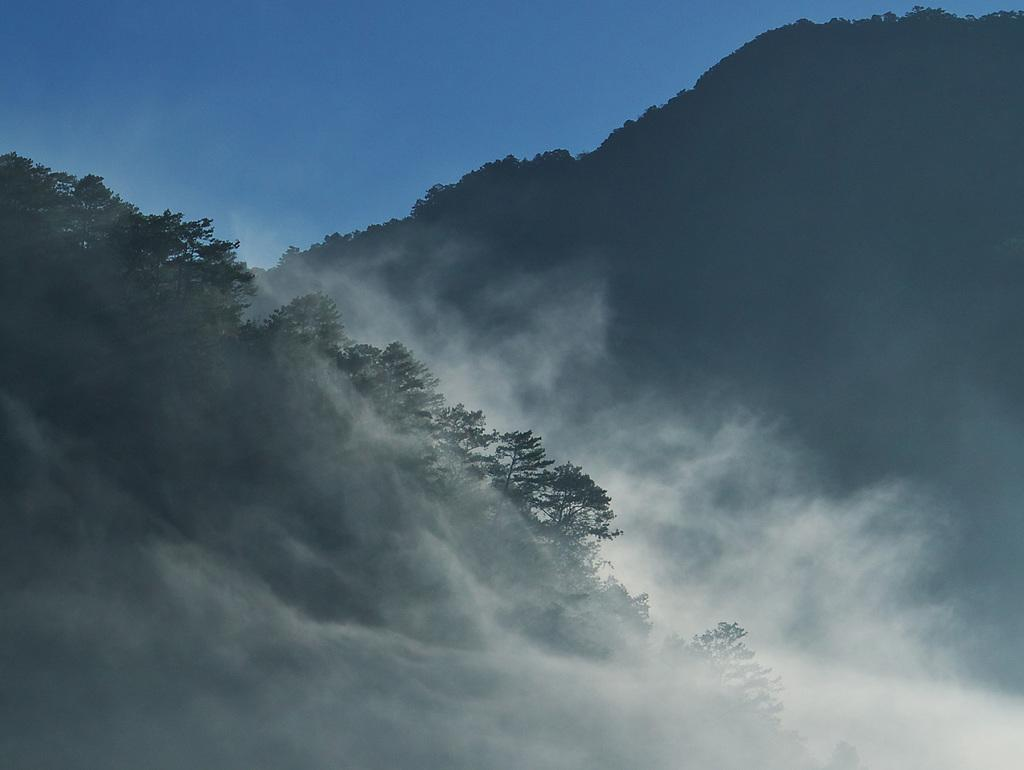What is present in the front of the image? There is fog in the front of the image. What can be seen on the left side of the image? There are trees on the left side of the image. What is visible at the top of the image? The sky is visible at the top of the image. What month is it in the image? The month cannot be determined from the image, as there is no information about the time of year. Can you tell me how many people are running in the image? There are no people visible in the image, let alone running. 